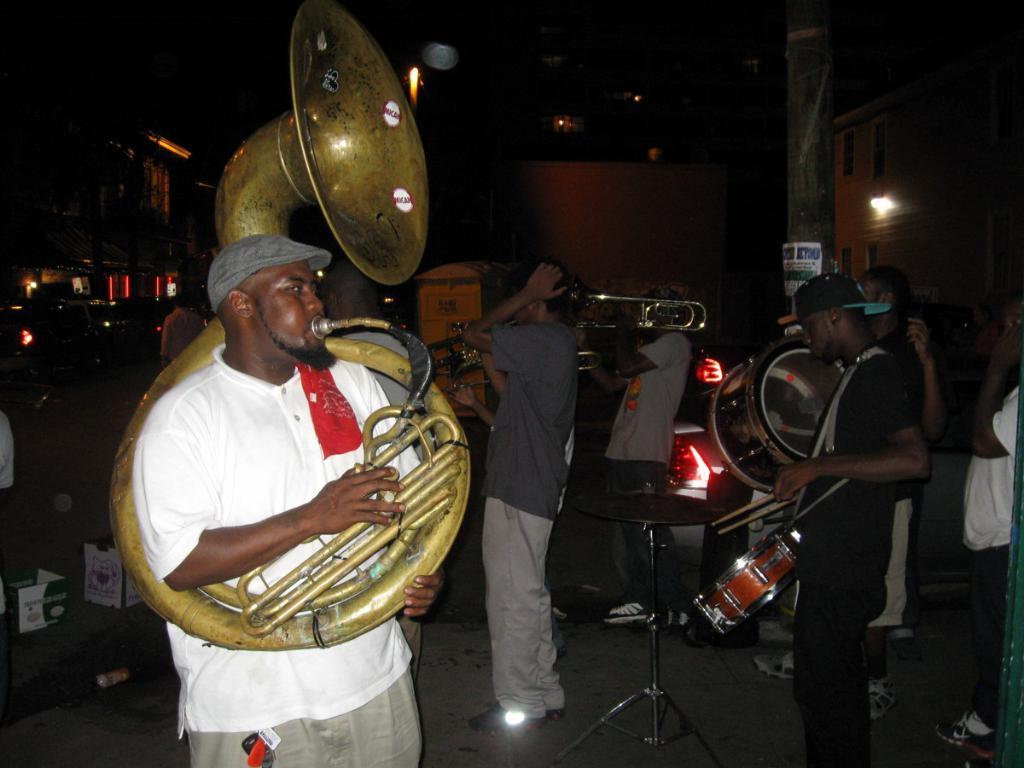Could you give a brief overview of what you see in this image? In this image we can see some persons, musical instruments and other objects. In the background of the image there are buildings, vehicles and other objects. 